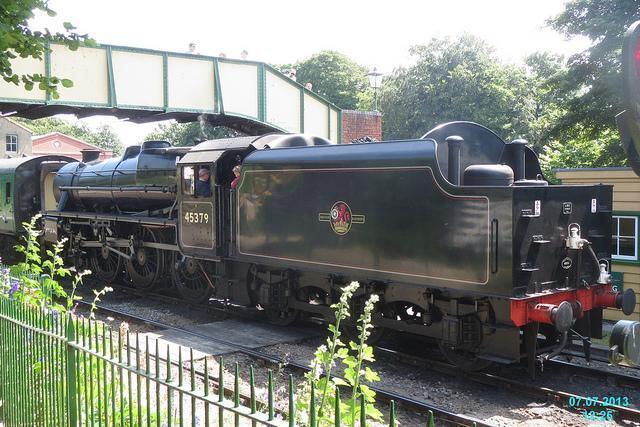What sort of traffic is allowed on the bridge over this train?
Choose the correct response, then elucidate: 'Answer: answer
Rationale: rationale.'
Options: Foot, boat, none, large trucks. Answer: foot.
Rationale: There is a very narrow crossing over the tracks 